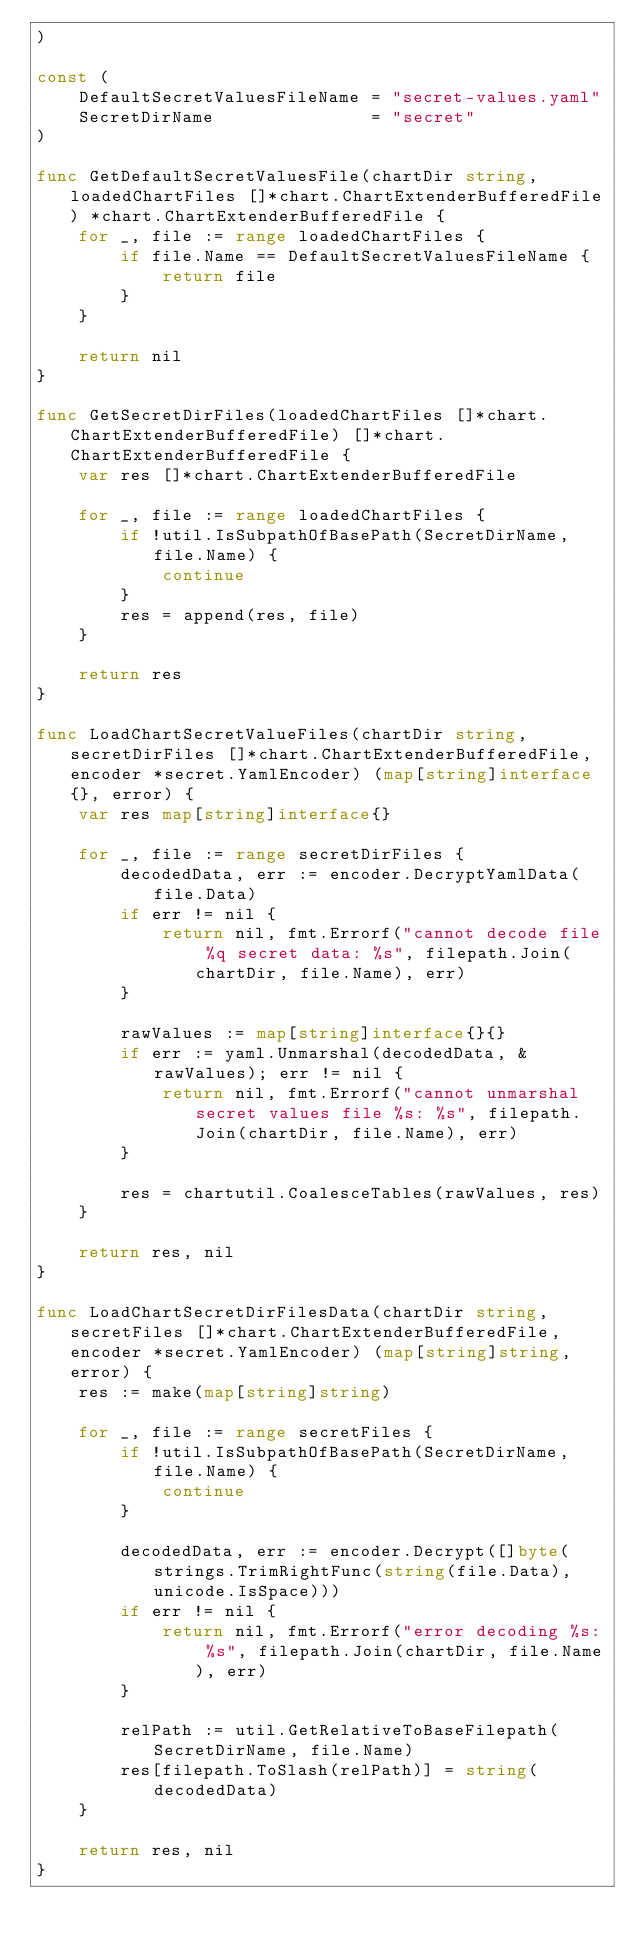<code> <loc_0><loc_0><loc_500><loc_500><_Go_>)

const (
	DefaultSecretValuesFileName = "secret-values.yaml"
	SecretDirName               = "secret"
)

func GetDefaultSecretValuesFile(chartDir string, loadedChartFiles []*chart.ChartExtenderBufferedFile) *chart.ChartExtenderBufferedFile {
	for _, file := range loadedChartFiles {
		if file.Name == DefaultSecretValuesFileName {
			return file
		}
	}

	return nil
}

func GetSecretDirFiles(loadedChartFiles []*chart.ChartExtenderBufferedFile) []*chart.ChartExtenderBufferedFile {
	var res []*chart.ChartExtenderBufferedFile

	for _, file := range loadedChartFiles {
		if !util.IsSubpathOfBasePath(SecretDirName, file.Name) {
			continue
		}
		res = append(res, file)
	}

	return res
}

func LoadChartSecretValueFiles(chartDir string, secretDirFiles []*chart.ChartExtenderBufferedFile, encoder *secret.YamlEncoder) (map[string]interface{}, error) {
	var res map[string]interface{}

	for _, file := range secretDirFiles {
		decodedData, err := encoder.DecryptYamlData(file.Data)
		if err != nil {
			return nil, fmt.Errorf("cannot decode file %q secret data: %s", filepath.Join(chartDir, file.Name), err)
		}

		rawValues := map[string]interface{}{}
		if err := yaml.Unmarshal(decodedData, &rawValues); err != nil {
			return nil, fmt.Errorf("cannot unmarshal secret values file %s: %s", filepath.Join(chartDir, file.Name), err)
		}

		res = chartutil.CoalesceTables(rawValues, res)
	}

	return res, nil
}

func LoadChartSecretDirFilesData(chartDir string, secretFiles []*chart.ChartExtenderBufferedFile, encoder *secret.YamlEncoder) (map[string]string, error) {
	res := make(map[string]string)

	for _, file := range secretFiles {
		if !util.IsSubpathOfBasePath(SecretDirName, file.Name) {
			continue
		}

		decodedData, err := encoder.Decrypt([]byte(strings.TrimRightFunc(string(file.Data), unicode.IsSpace)))
		if err != nil {
			return nil, fmt.Errorf("error decoding %s: %s", filepath.Join(chartDir, file.Name), err)
		}

		relPath := util.GetRelativeToBaseFilepath(SecretDirName, file.Name)
		res[filepath.ToSlash(relPath)] = string(decodedData)
	}

	return res, nil
}
</code> 